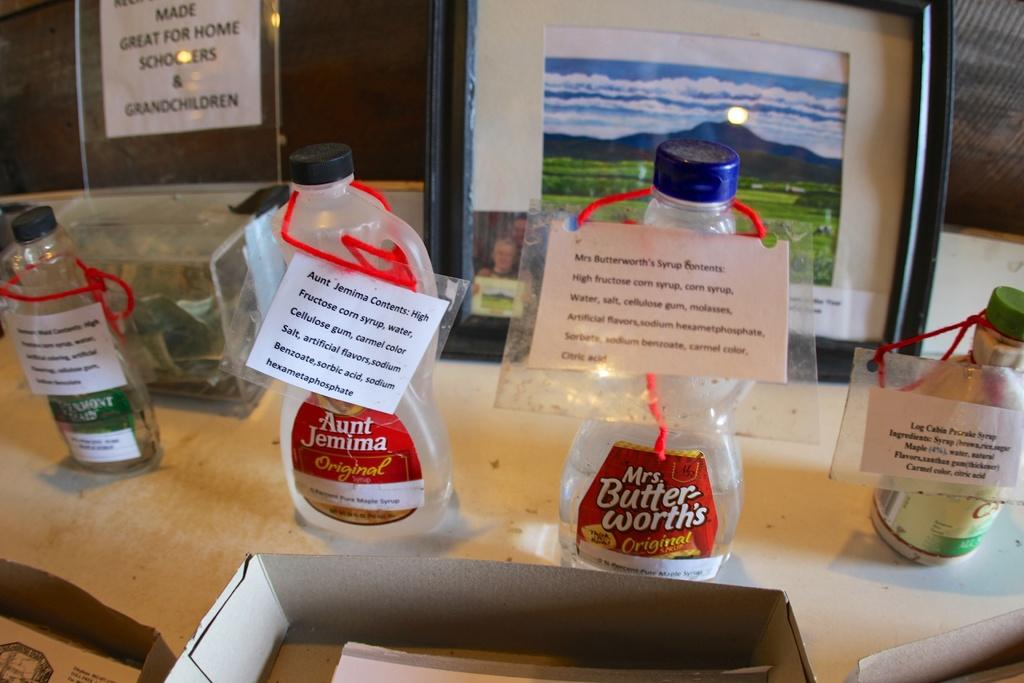<image>
Create a compact narrative representing the image presented. Empty bottles of Aunt Jemima and Mrs. Butterworths syrup bottles with white notes tied with red yarn 